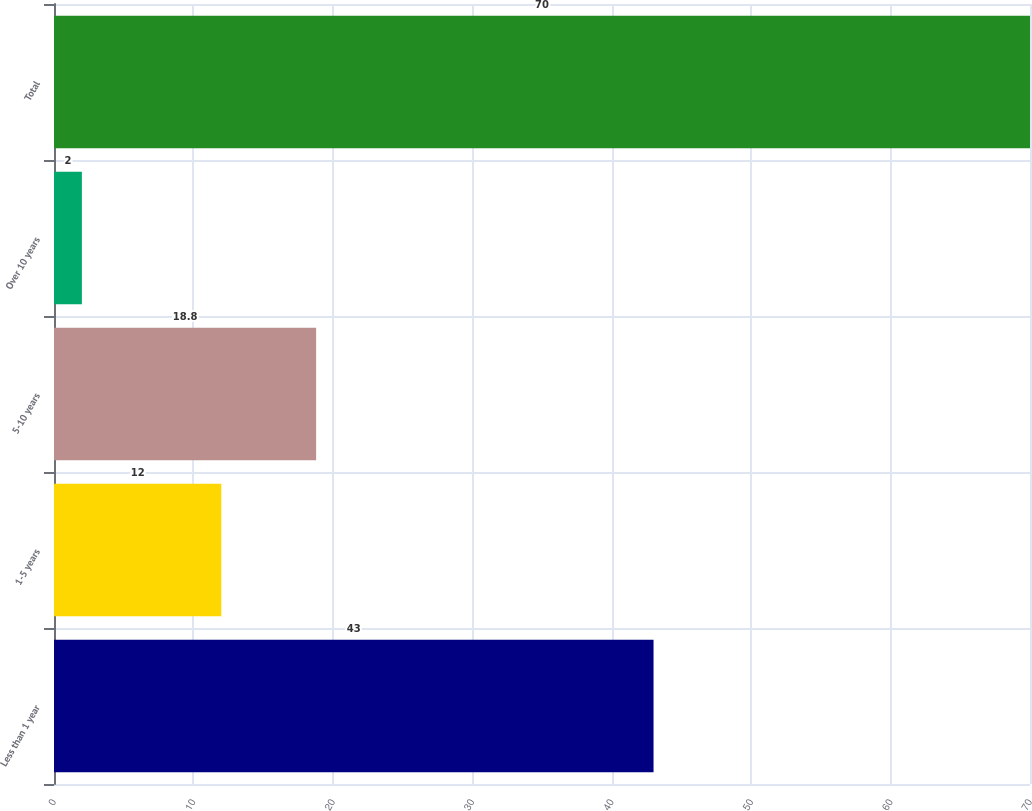Convert chart to OTSL. <chart><loc_0><loc_0><loc_500><loc_500><bar_chart><fcel>Less than 1 year<fcel>1-5 years<fcel>5-10 years<fcel>Over 10 years<fcel>Total<nl><fcel>43<fcel>12<fcel>18.8<fcel>2<fcel>70<nl></chart> 